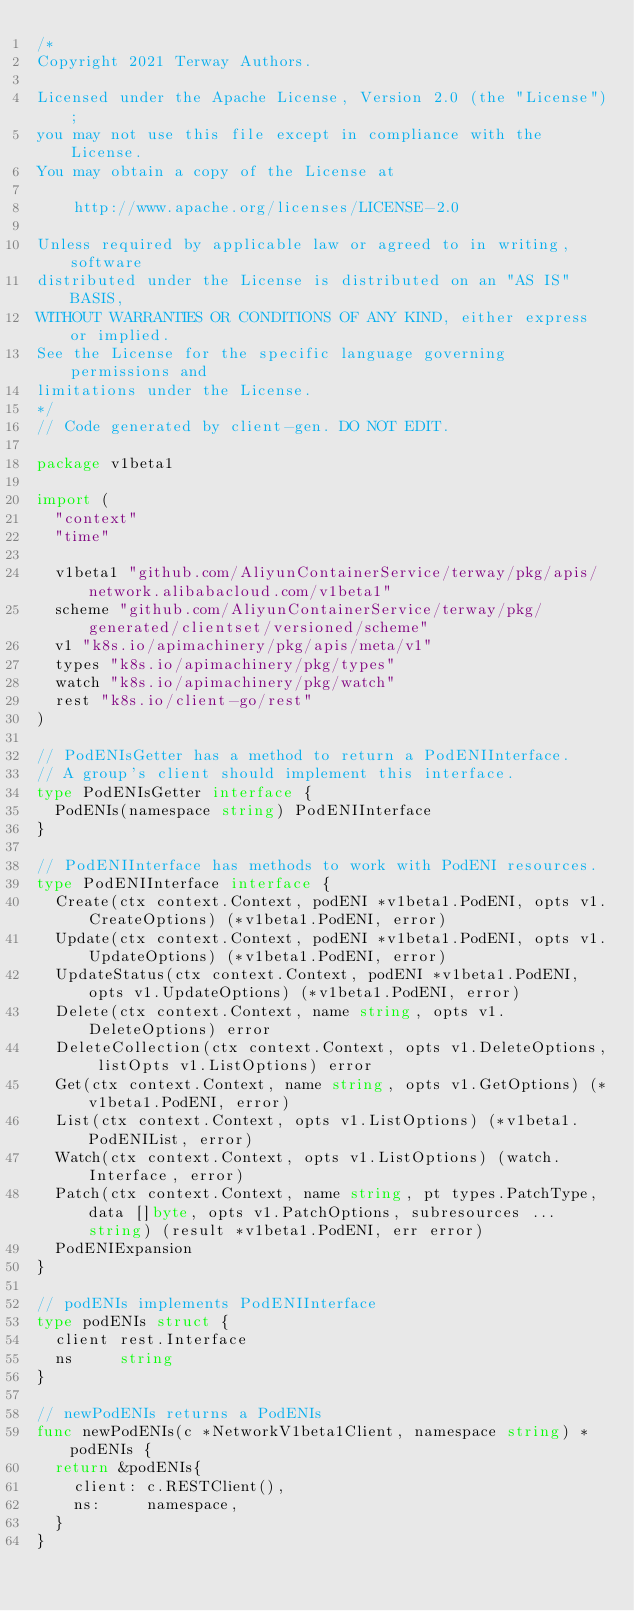<code> <loc_0><loc_0><loc_500><loc_500><_Go_>/*
Copyright 2021 Terway Authors.

Licensed under the Apache License, Version 2.0 (the "License");
you may not use this file except in compliance with the License.
You may obtain a copy of the License at

    http://www.apache.org/licenses/LICENSE-2.0

Unless required by applicable law or agreed to in writing, software
distributed under the License is distributed on an "AS IS" BASIS,
WITHOUT WARRANTIES OR CONDITIONS OF ANY KIND, either express or implied.
See the License for the specific language governing permissions and
limitations under the License.
*/
// Code generated by client-gen. DO NOT EDIT.

package v1beta1

import (
	"context"
	"time"

	v1beta1 "github.com/AliyunContainerService/terway/pkg/apis/network.alibabacloud.com/v1beta1"
	scheme "github.com/AliyunContainerService/terway/pkg/generated/clientset/versioned/scheme"
	v1 "k8s.io/apimachinery/pkg/apis/meta/v1"
	types "k8s.io/apimachinery/pkg/types"
	watch "k8s.io/apimachinery/pkg/watch"
	rest "k8s.io/client-go/rest"
)

// PodENIsGetter has a method to return a PodENIInterface.
// A group's client should implement this interface.
type PodENIsGetter interface {
	PodENIs(namespace string) PodENIInterface
}

// PodENIInterface has methods to work with PodENI resources.
type PodENIInterface interface {
	Create(ctx context.Context, podENI *v1beta1.PodENI, opts v1.CreateOptions) (*v1beta1.PodENI, error)
	Update(ctx context.Context, podENI *v1beta1.PodENI, opts v1.UpdateOptions) (*v1beta1.PodENI, error)
	UpdateStatus(ctx context.Context, podENI *v1beta1.PodENI, opts v1.UpdateOptions) (*v1beta1.PodENI, error)
	Delete(ctx context.Context, name string, opts v1.DeleteOptions) error
	DeleteCollection(ctx context.Context, opts v1.DeleteOptions, listOpts v1.ListOptions) error
	Get(ctx context.Context, name string, opts v1.GetOptions) (*v1beta1.PodENI, error)
	List(ctx context.Context, opts v1.ListOptions) (*v1beta1.PodENIList, error)
	Watch(ctx context.Context, opts v1.ListOptions) (watch.Interface, error)
	Patch(ctx context.Context, name string, pt types.PatchType, data []byte, opts v1.PatchOptions, subresources ...string) (result *v1beta1.PodENI, err error)
	PodENIExpansion
}

// podENIs implements PodENIInterface
type podENIs struct {
	client rest.Interface
	ns     string
}

// newPodENIs returns a PodENIs
func newPodENIs(c *NetworkV1beta1Client, namespace string) *podENIs {
	return &podENIs{
		client: c.RESTClient(),
		ns:     namespace,
	}
}
</code> 